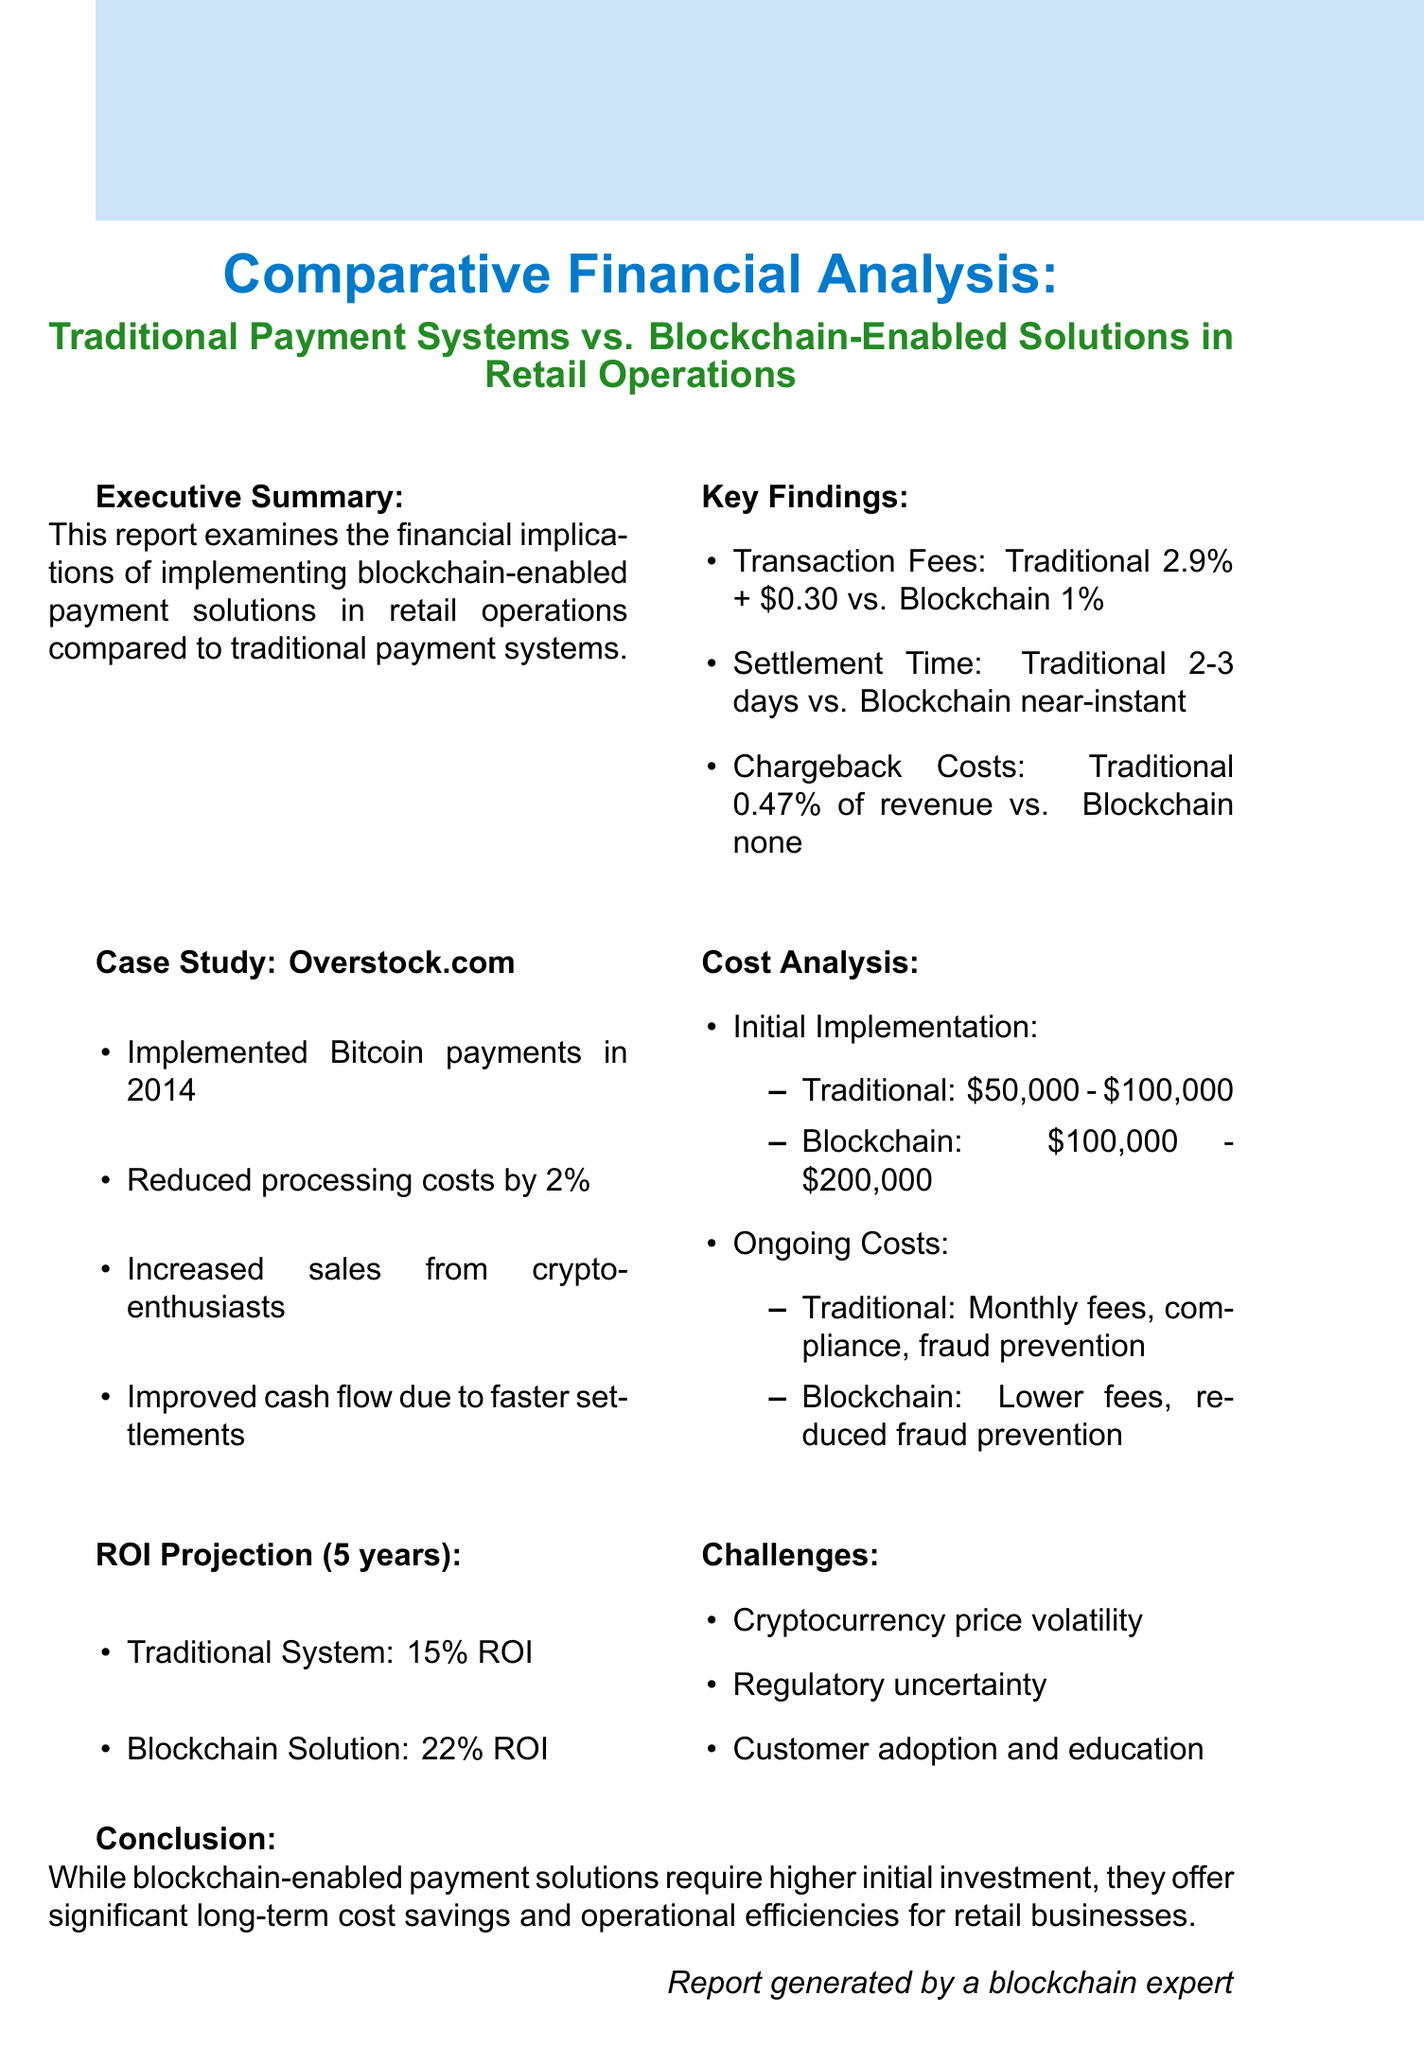What is the average transaction fee for traditional payment systems? The document states that the average transaction fee for traditional payment systems is 2.9% + $0.30 for credit card payments.
Answer: 2.9% + $0.30 What is the average transaction fee for blockchain-enabled solutions? According to the report, the average transaction fee for blockchain-enabled solutions is 1% for cryptocurrency payments.
Answer: 1% What was the initial implementation cost range for traditional systems? The document states that the initial implementation cost for traditional systems ranges from $50,000 to $100,000.
Answer: $50,000 - $100,000 What is the ROI projection for blockchain solutions over five years? The ROI projection for blockchain solutions over five years, as per the report, is 22%.
Answer: 22% Which company is used as a case study in the report? The case study in the report focuses on Overstock.com.
Answer: Overstock.com What challenge is related to cryptocurrency mentioned in the report? The report mentions the volatility of cryptocurrency prices as a challenge.
Answer: Volatility of cryptocurrency prices How much did Overstock.com reduce payment processing costs by? The report states that Overstock.com reduced payment processing costs by 2%.
Answer: 2% What is the settlement time for blockchain solutions? According to the report, the settlement time for blockchain solutions is near-instant, typically taking an average of 10 minutes for Bitcoin.
Answer: Near-instant What is a significant advantage of blockchain-enabled solutions regarding chargebacks? The report claims that blockchain solutions have no chargebacks, which reduces fraud-related costs.
Answer: No chargebacks 